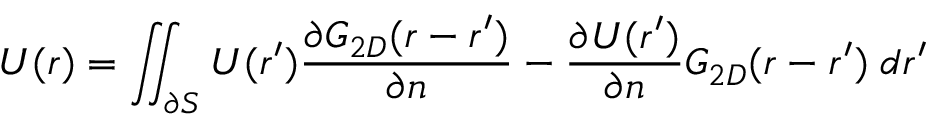Convert formula to latex. <formula><loc_0><loc_0><loc_500><loc_500>U ( r ) = \iint _ { \partial S } U ( r ^ { \prime } ) \frac { \partial G _ { 2 D } ( r - r ^ { \prime } ) } { \partial n } - \frac { \partial U ( r ^ { \prime } ) } { \partial n } G _ { 2 D } ( r - r ^ { \prime } ) \, d r ^ { \prime }</formula> 